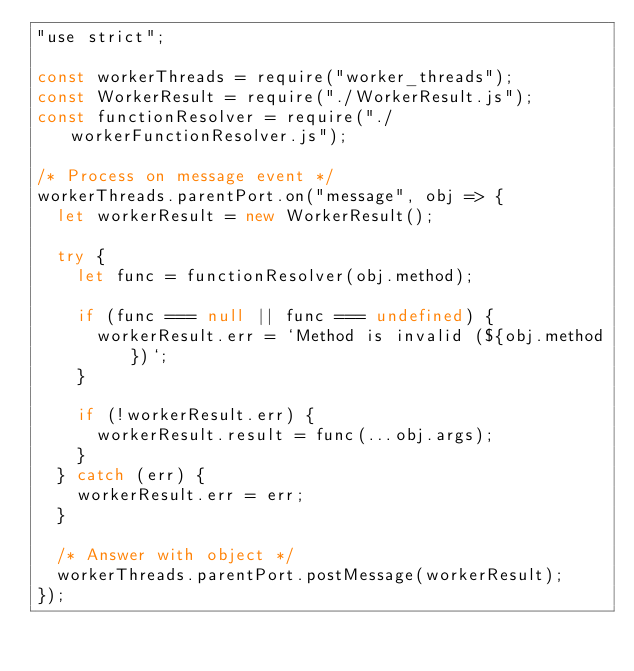Convert code to text. <code><loc_0><loc_0><loc_500><loc_500><_JavaScript_>"use strict";

const workerThreads = require("worker_threads");
const WorkerResult = require("./WorkerResult.js");
const functionResolver = require("./workerFunctionResolver.js");

/* Process on message event */
workerThreads.parentPort.on("message", obj => {
  let workerResult = new WorkerResult();

  try {
    let func = functionResolver(obj.method);

    if (func === null || func === undefined) {
      workerResult.err = `Method is invalid (${obj.method})`;
    }

    if (!workerResult.err) {
      workerResult.result = func(...obj.args);
    }
  } catch (err) {
    workerResult.err = err;
  }

  /* Answer with object */
  workerThreads.parentPort.postMessage(workerResult);
});
</code> 